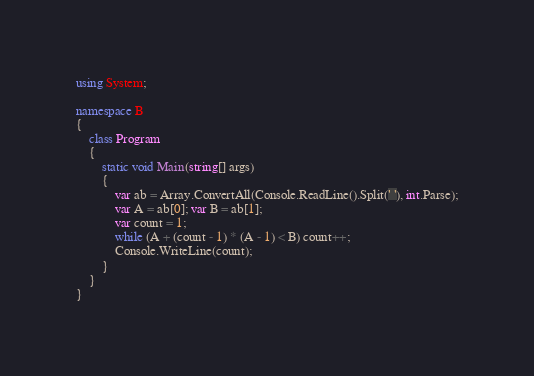Convert code to text. <code><loc_0><loc_0><loc_500><loc_500><_C#_>using System;

namespace B
{
    class Program
    {
        static void Main(string[] args)
        {
            var ab = Array.ConvertAll(Console.ReadLine().Split(' '), int.Parse);
            var A = ab[0]; var B = ab[1];
            var count = 1;
            while (A + (count - 1) * (A - 1) < B) count++;
            Console.WriteLine(count);
        }
    }
}
</code> 